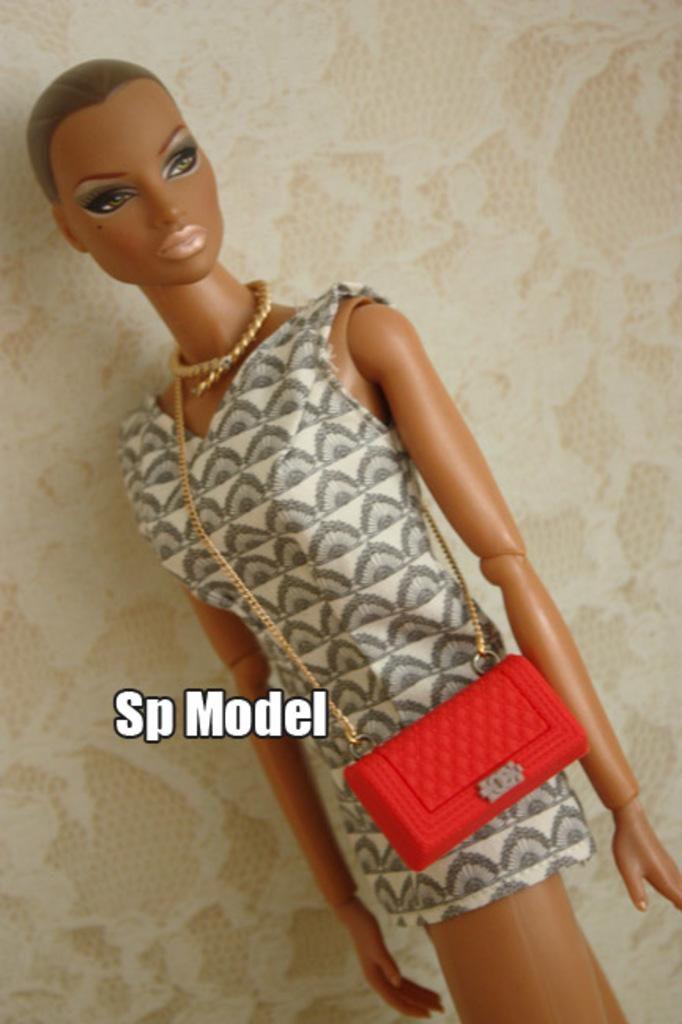What is the main subject of the picture? The main subject of the picture is a doll. What else can be seen in the center of the picture? There is text in the center of the picture. What can be observed in the background of the picture? There is a design on the wall in the background of the picture. How many bears are holding crayons in the image? There are no bears or crayons present in the image. What type of coach is visible in the background of the image? There is no coach present in the image; it features a doll, text, and a design on the wall. 